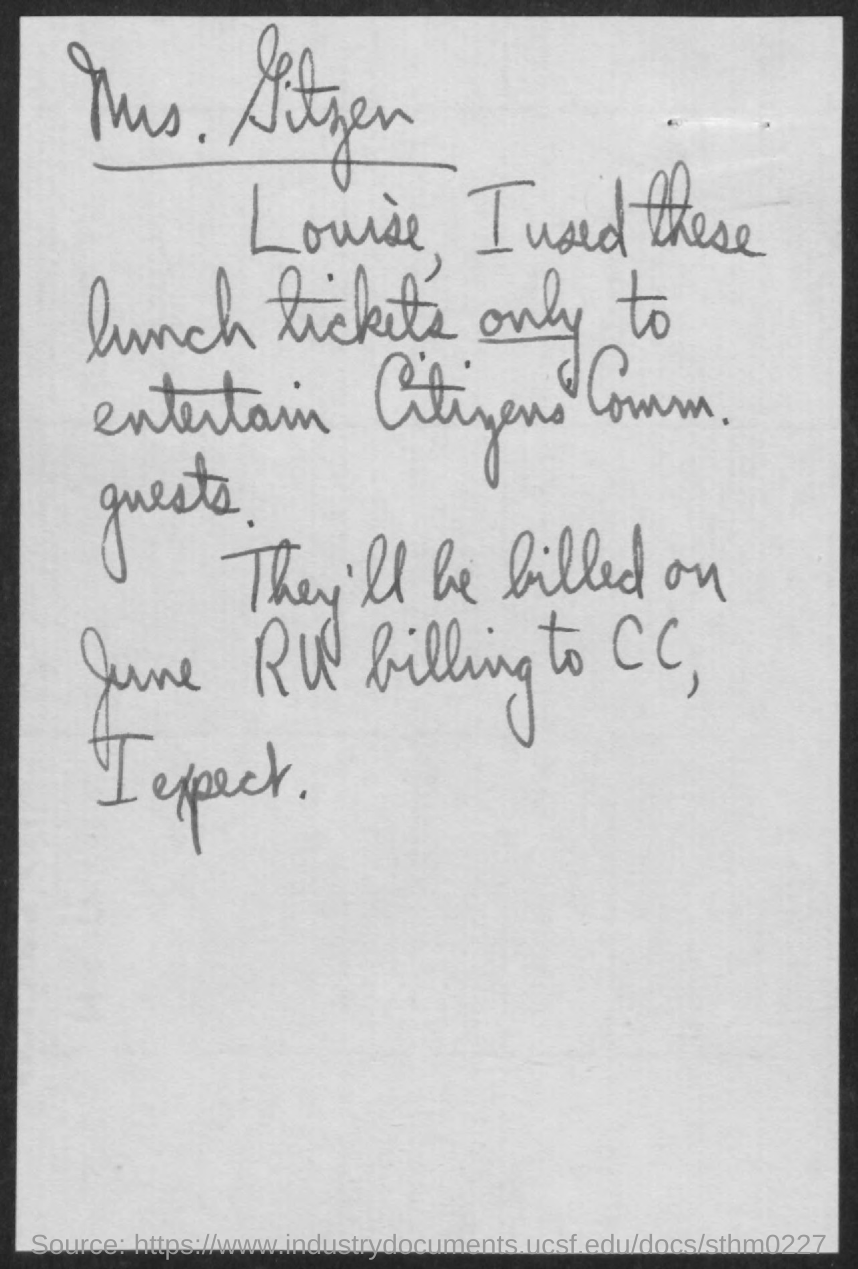Indicate a few pertinent items in this graphic. The document mentions June. 